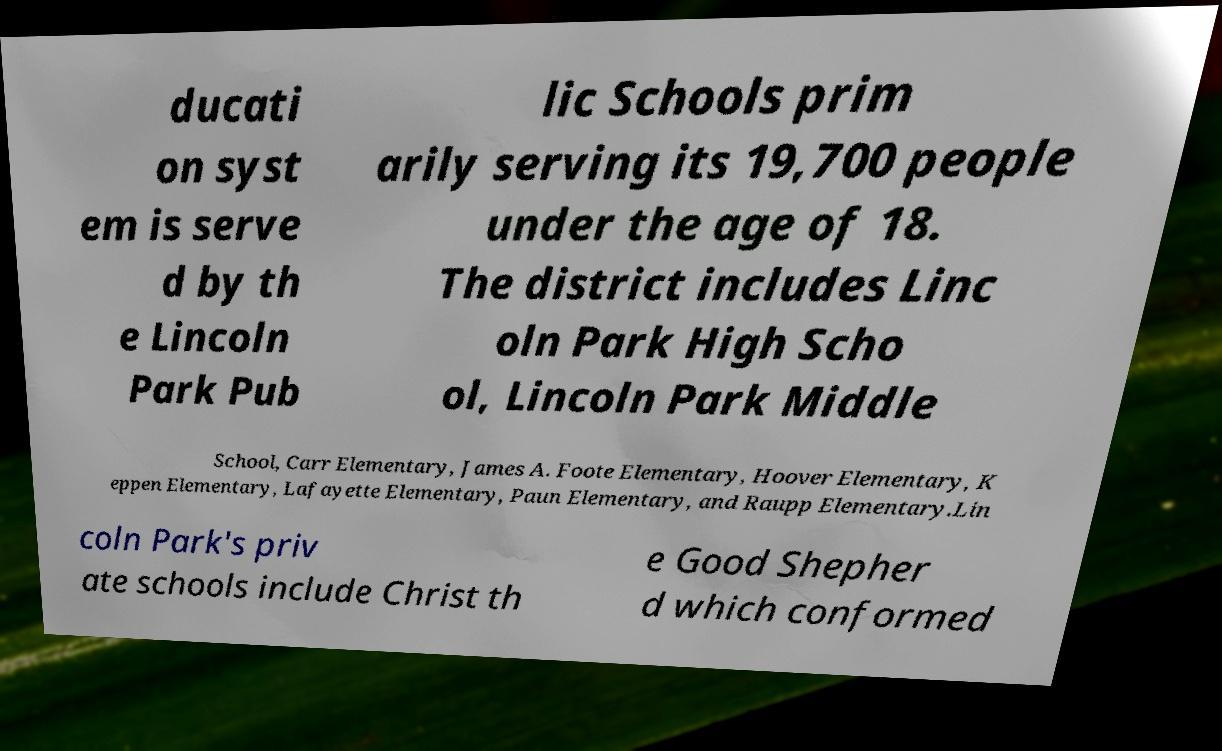What messages or text are displayed in this image? I need them in a readable, typed format. ducati on syst em is serve d by th e Lincoln Park Pub lic Schools prim arily serving its 19,700 people under the age of 18. The district includes Linc oln Park High Scho ol, Lincoln Park Middle School, Carr Elementary, James A. Foote Elementary, Hoover Elementary, K eppen Elementary, Lafayette Elementary, Paun Elementary, and Raupp Elementary.Lin coln Park's priv ate schools include Christ th e Good Shepher d which conformed 